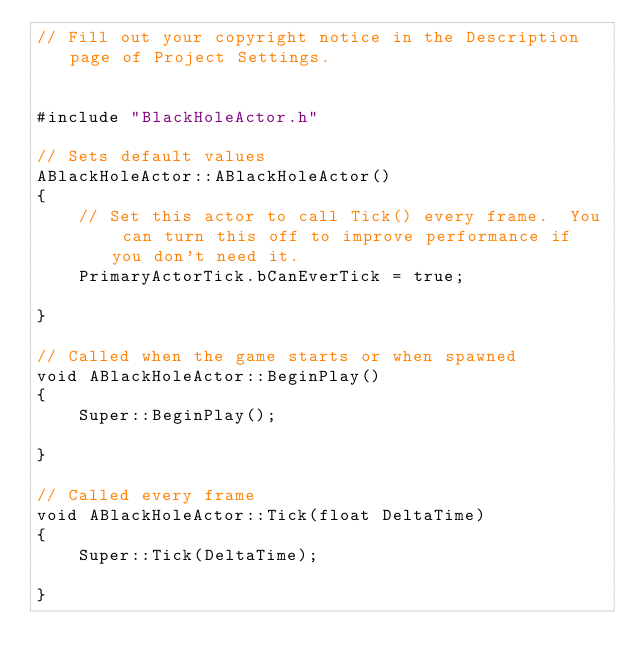<code> <loc_0><loc_0><loc_500><loc_500><_C++_>// Fill out your copyright notice in the Description page of Project Settings.


#include "BlackHoleActor.h"

// Sets default values
ABlackHoleActor::ABlackHoleActor()
{
 	// Set this actor to call Tick() every frame.  You can turn this off to improve performance if you don't need it.
	PrimaryActorTick.bCanEverTick = true;

}

// Called when the game starts or when spawned
void ABlackHoleActor::BeginPlay()
{
	Super::BeginPlay();
	
}

// Called every frame
void ABlackHoleActor::Tick(float DeltaTime)
{
	Super::Tick(DeltaTime);

}

</code> 